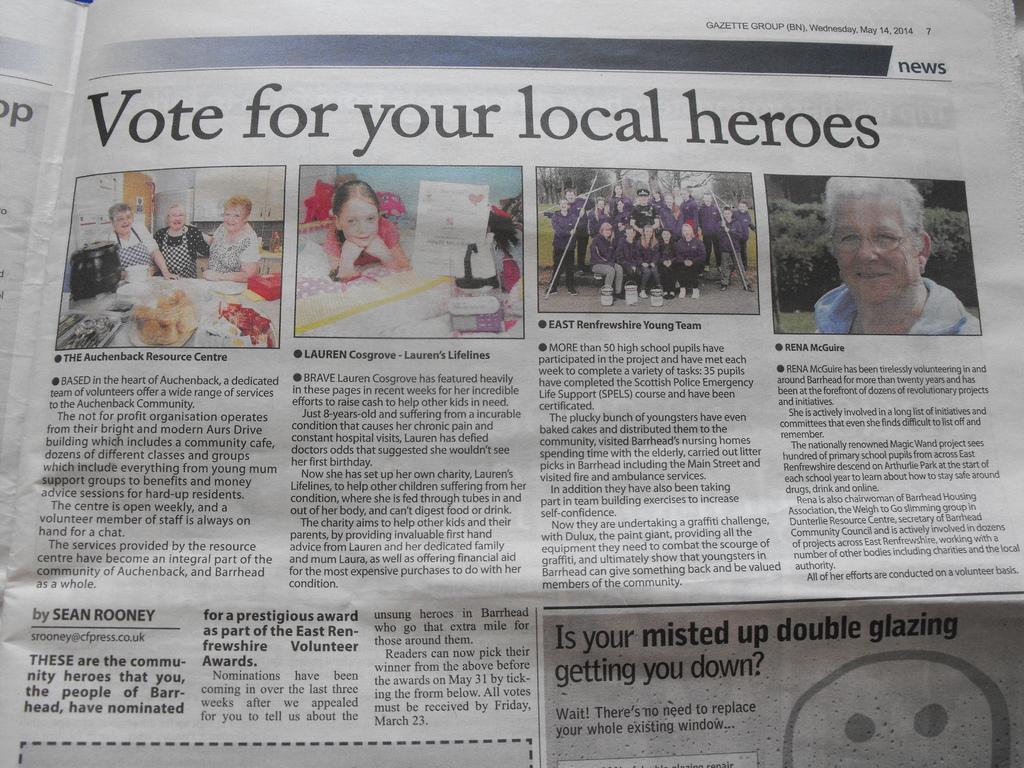Could you give a brief overview of what you see in this image? In this image we can see one newspaper with text, numbers and images. In this newspaper we can see some people sitting, some people standing, few people are holding objects, some objects on the table, some objects on the bed, one girl lying on the bed, two plates with wood, some objects on the ground, some objects behind the womenś, some trees and grass on the ground. 